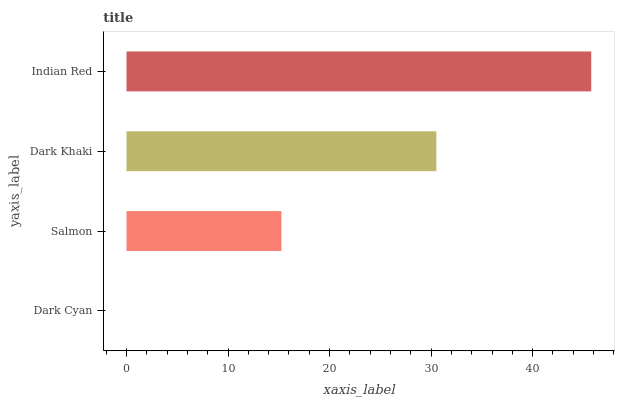Is Dark Cyan the minimum?
Answer yes or no. Yes. Is Indian Red the maximum?
Answer yes or no. Yes. Is Salmon the minimum?
Answer yes or no. No. Is Salmon the maximum?
Answer yes or no. No. Is Salmon greater than Dark Cyan?
Answer yes or no. Yes. Is Dark Cyan less than Salmon?
Answer yes or no. Yes. Is Dark Cyan greater than Salmon?
Answer yes or no. No. Is Salmon less than Dark Cyan?
Answer yes or no. No. Is Dark Khaki the high median?
Answer yes or no. Yes. Is Salmon the low median?
Answer yes or no. Yes. Is Salmon the high median?
Answer yes or no. No. Is Dark Khaki the low median?
Answer yes or no. No. 